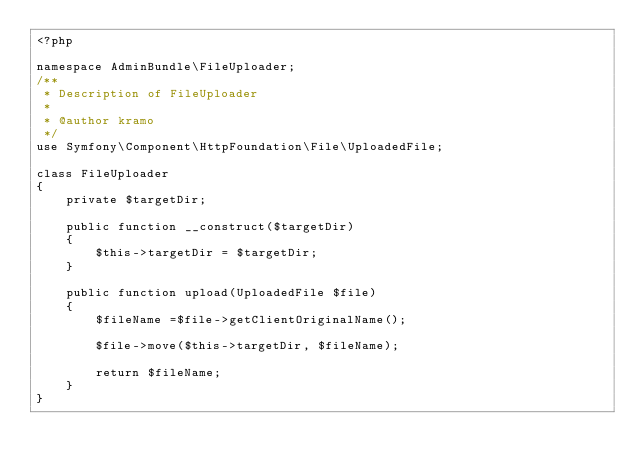<code> <loc_0><loc_0><loc_500><loc_500><_PHP_><?php

namespace AdminBundle\FileUploader;
/**
 * Description of FileUploader
 *
 * @author kramo
 */
use Symfony\Component\HttpFoundation\File\UploadedFile;

class FileUploader
{
    private $targetDir;

    public function __construct($targetDir)
    {
        $this->targetDir = $targetDir;
    }

    public function upload(UploadedFile $file)
    {
        $fileName =$file->getClientOriginalName();

        $file->move($this->targetDir, $fileName);

        return $fileName;
    }
}</code> 